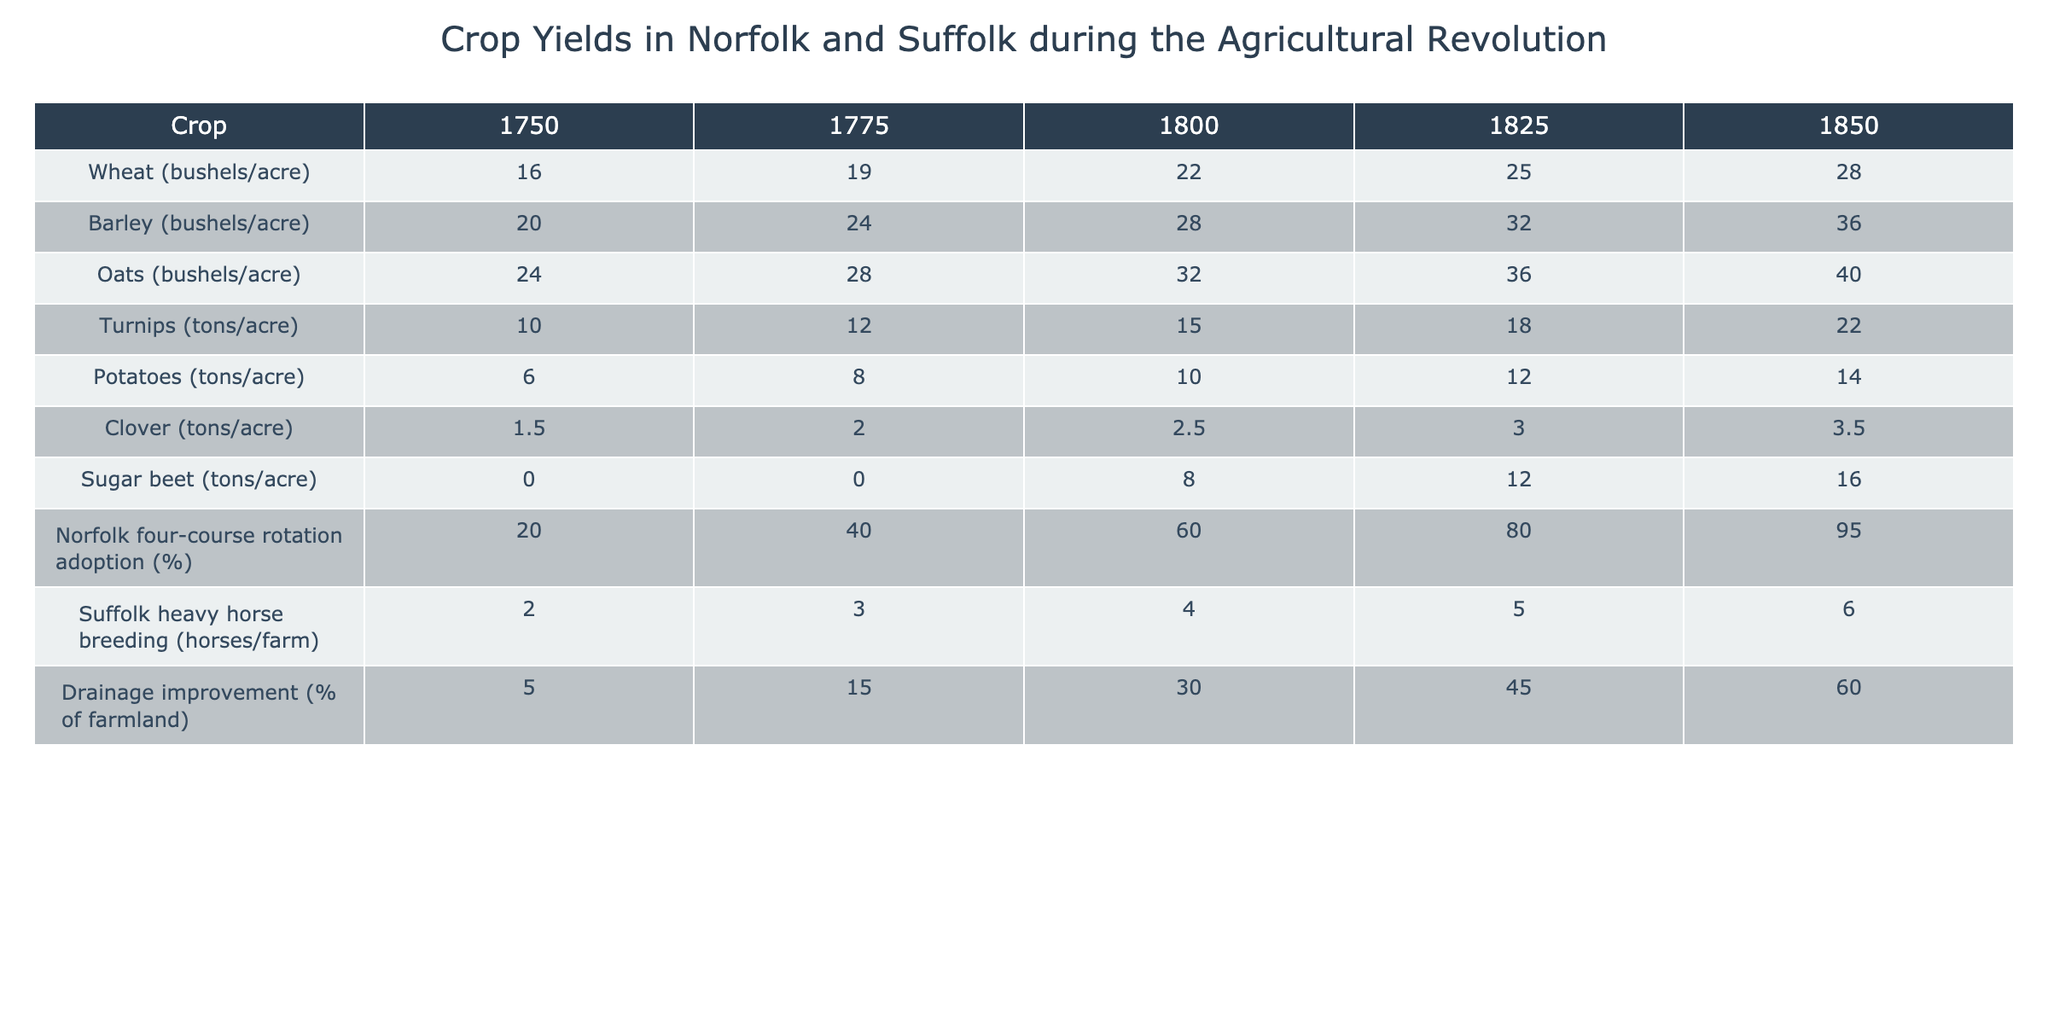What was the wheat yield per acre in 1800? In the table under the column for the year 1800 and the crop Wheat, the value listed is 22 bushels per acre.
Answer: 22 bushels/acre What was the increase in oat yield from 1750 to 1850? The oat yield in 1750 was 24 bushels per acre, and in 1850 it was 40 bushels per acre. The increase is 40 - 24 = 16 bushels per acre.
Answer: 16 bushels/acre Did the adoption of the Norfolk four-course rotation reach 80% by 1825? In the table, the adoption percentage for the year 1825 is listed as 80%. Therefore, the statement is true.
Answer: Yes What was the average potato yield from 1750 to 1850? The potato yields for the years provided are 6, 8, 10, 12, and 14 tons per acre. The sum is 6 + 8 + 10 + 12 + 14 = 50. There are 5 data points, so the average is 50/5 = 10 tons per acre.
Answer: 10 tons/acre How many tons of turnips were produced per acre in 1775? Referring to the table, the turnip yield for the year 1775 is 12 tons per acre.
Answer: 12 tons/acre What trend can be observed in the sugar beet yield from 1800 to 1850? The sugar beet yield in 1800 was 8 tons per acre and increased to 16 tons per acre by 1850. This indicates an increase of 8 tons per acre, reflecting a growth trend over that period.
Answer: Increasing What percentage of farmland saw drainage improvements by 1850? According to the table, the percentage of farmland with drainage improvements in 1850 was 60%.
Answer: 60% What was the difference in barley yield between 1750 and 1825? The barley yield in 1750 was 20 bushels per acre and in 1825 it was 32 bushels per acre. The difference is 32 - 20 = 12 bushels per acre.
Answer: 12 bushels/acre What was the highest yield of clover recorded in the table? The highest yield of clover listed in the table is 3.5 tons per acre in 1850.
Answer: 3.5 tons/acre If the number of horses per farm in Suffolk increased continuously from 2 to 6 between 1750 and 1850, what was the average yearly increase? The number of horses increased from 2 to 6 over 100 years (from 1750 to 1850), resulting in a total increase of 6 - 2 = 4 horses. The average yearly increase is 4/100 = 0.04 horses per farm per year.
Answer: 0.04 horses/farm/year 